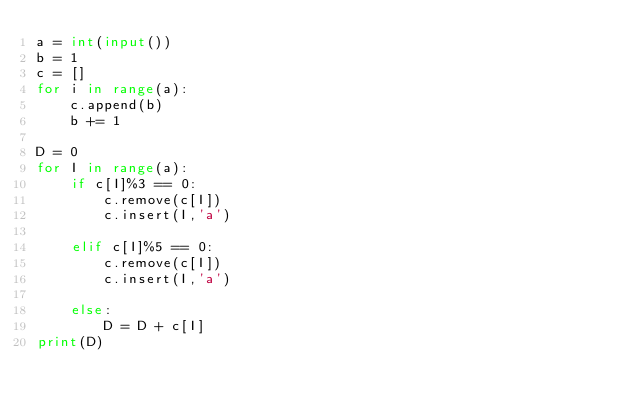Convert code to text. <code><loc_0><loc_0><loc_500><loc_500><_Python_>a = int(input())
b = 1
c = []
for i in range(a):
    c.append(b)
    b += 1

D = 0
for I in range(a):
    if c[I]%3 == 0:
        c.remove(c[I])
        c.insert(I,'a')
    
    elif c[I]%5 == 0:
        c.remove(c[I])
        c.insert(I,'a')
        
    else:
        D = D + c[I]
print(D)</code> 